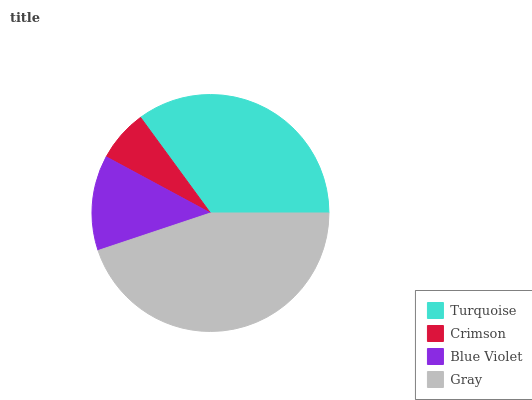Is Crimson the minimum?
Answer yes or no. Yes. Is Gray the maximum?
Answer yes or no. Yes. Is Blue Violet the minimum?
Answer yes or no. No. Is Blue Violet the maximum?
Answer yes or no. No. Is Blue Violet greater than Crimson?
Answer yes or no. Yes. Is Crimson less than Blue Violet?
Answer yes or no. Yes. Is Crimson greater than Blue Violet?
Answer yes or no. No. Is Blue Violet less than Crimson?
Answer yes or no. No. Is Turquoise the high median?
Answer yes or no. Yes. Is Blue Violet the low median?
Answer yes or no. Yes. Is Blue Violet the high median?
Answer yes or no. No. Is Gray the low median?
Answer yes or no. No. 